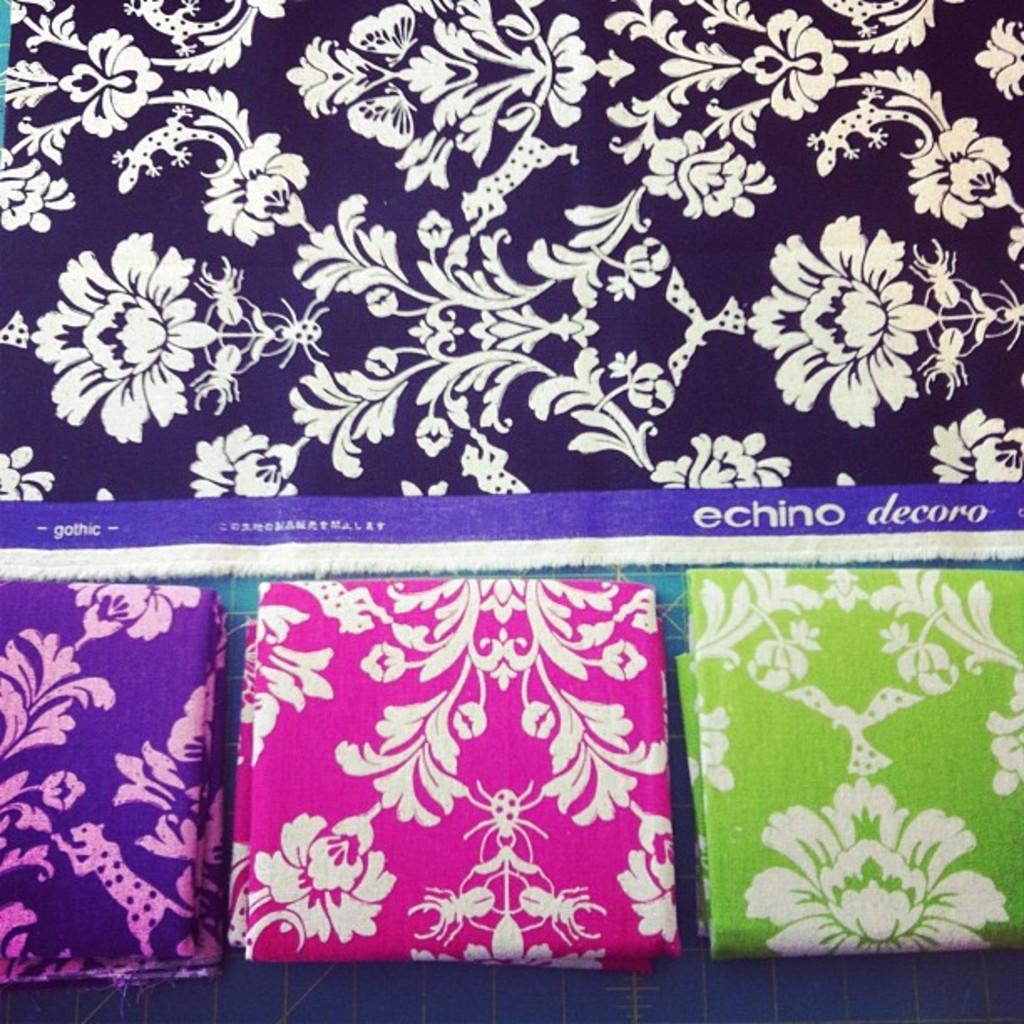In one or two sentences, can you explain what this image depicts? In this picture we can see clothes on the platform. 